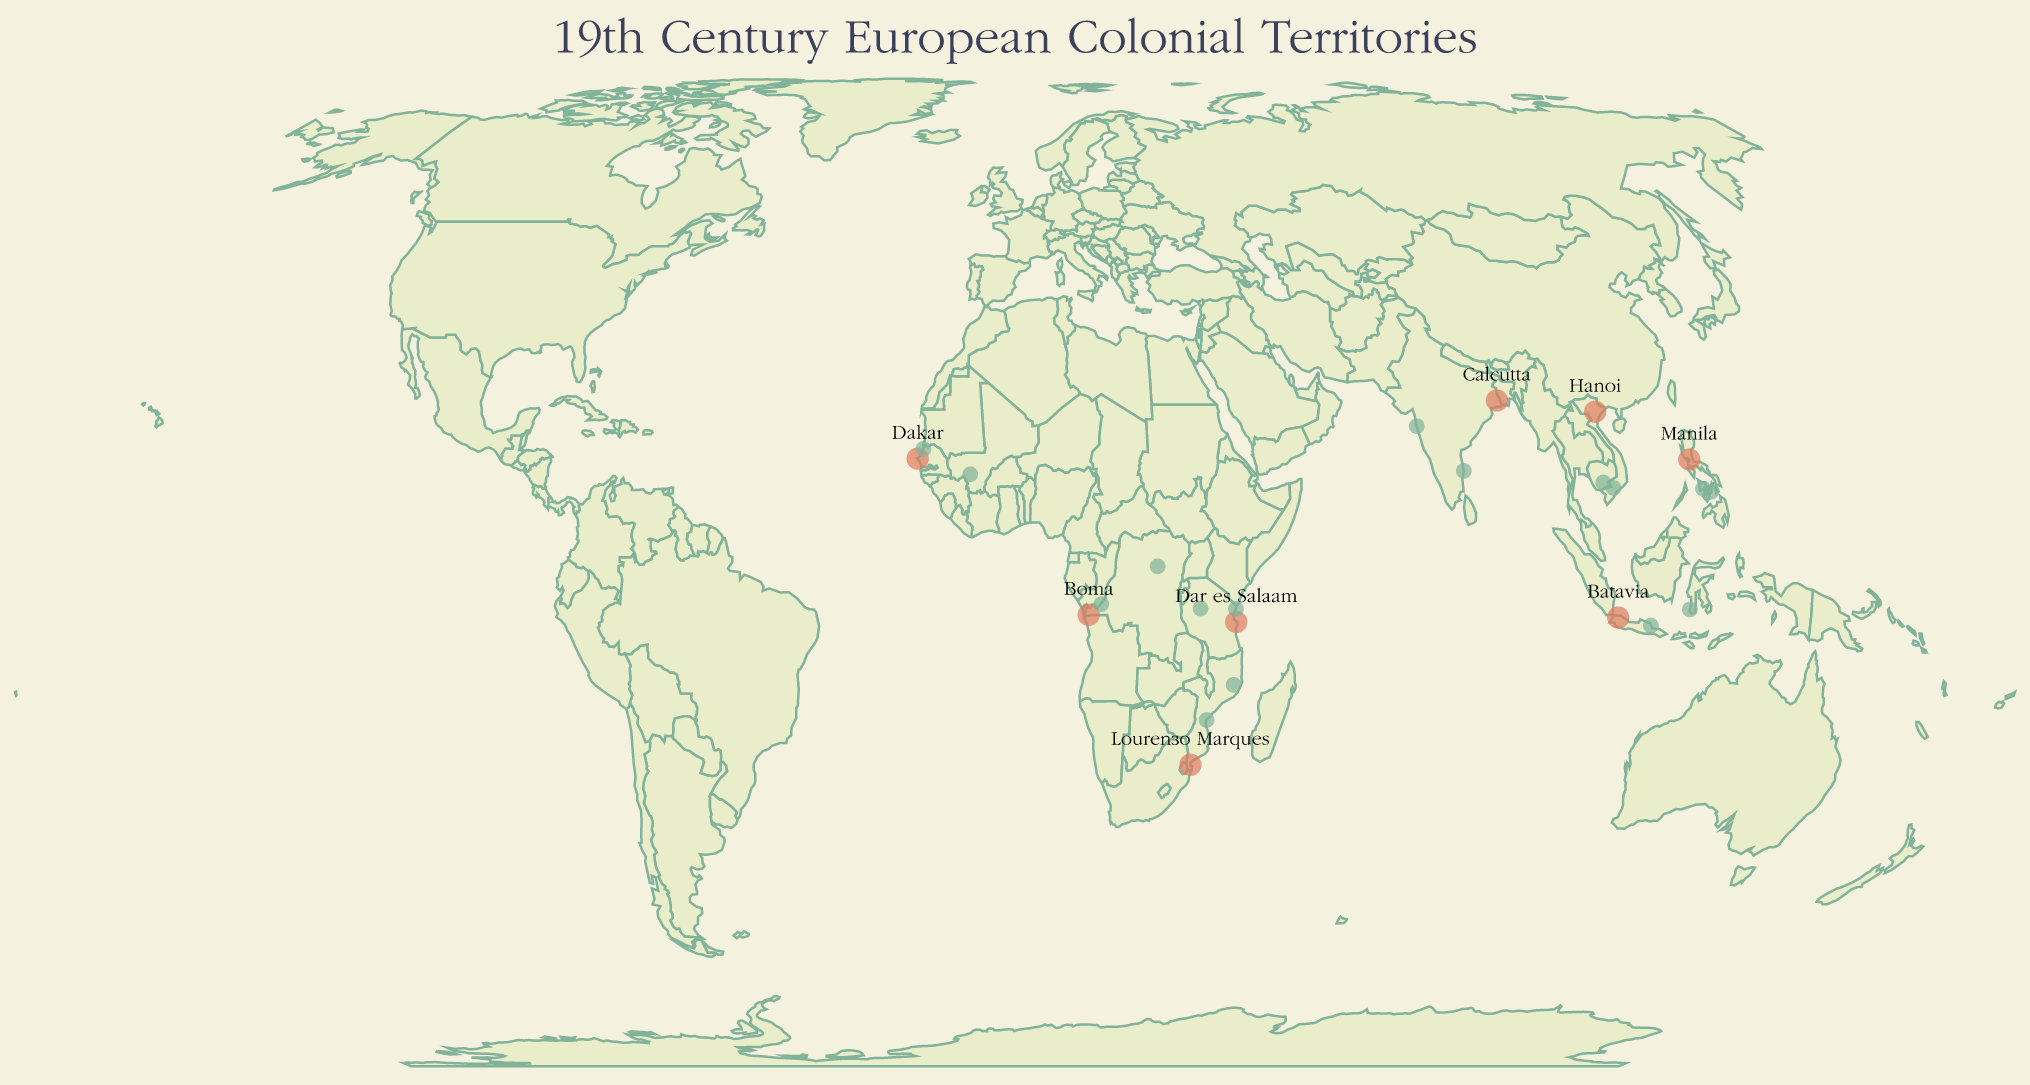What is the capital of British India as shown in the figure? The figure indicates the capital city of each territory using labels on the map. For British India, the labeled capital city is Calcutta.
Answer: Calcutta Which territory's capital is closest to the equator? The equator is located at 0° latitude. Evaluating the latitudes of the listed capitals, Batavia (Dutch East Indies, -6.2088°) is the closest.
Answer: Batavia List three major trade routes shown in the figure. The figure displays the trade routes associated with each territory. Examples include the Silk Route, Spice Route, and Galleon Trade.
Answer: Silk Route, Spice Route, Galleon Trade Compare the latitudes of French Indochina's major city 1 and major city 2, and determine which one is further south. Saigon (10.8231° N) and Phnom Penh (11.5564° N) are the major cities. Saigon has the smaller latitude value, indicating it is further south.
Answer: Saigon Which territory spans both the eastern and western hemispheres based on its given coordinates? French West Africa's capital Dakar has a longitude of -17.4677, placing it near the Prime Meridian in the western hemisphere, but its other major cities (e.g., Bamako) extend into the eastern hemisphere based on their coordinates.
Answer: French West Africa Identify the trade route associated with Portuguese Mozambique. Reviewing the labeled trade routes for each territory identifies the Swahili Coast Trade as the route for Portuguese Mozambique.
Answer: Swahili Coast Trade How many major cities are listed for German East Africa, based on the figure? The figure shows each territory with its capital and two major cities. For German East Africa, two major cities listed are Tanga and Tabora.
Answer: 2 Which capital is located at approximately -25.9692 latitude and 32.5732 longitude? Observing the coordinates, the capital at -25.9692 latitude and 32.5732 longitude is Lourenço Marques of Portuguese Mozambique.
Answer: Lourenço Marques What trade route is associated with Belgian Congo, and how does it compare with the trade route of British India? Belgian Congo is linked to the Congo River Trade, while British India is tied to the Silk Route. Each route indicates different geographical and economic connections.
Answer: Congo River Trade, Silk Route 